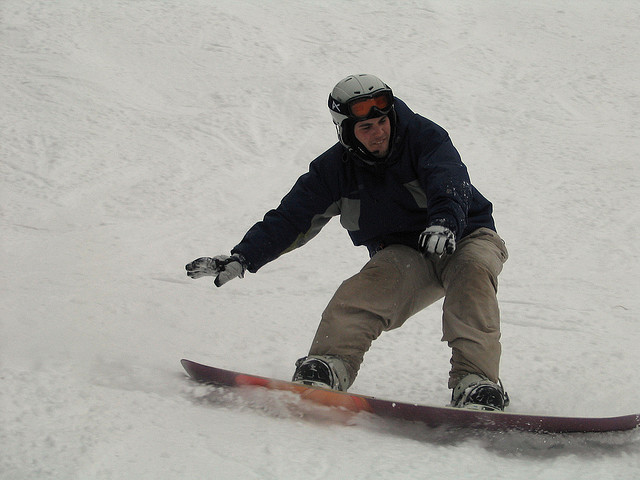<image>How fast is the man going? It is unknown how fast the man is going. How fast is the man going? I don't know how fast the man is going. It can be both fast or not fast. 